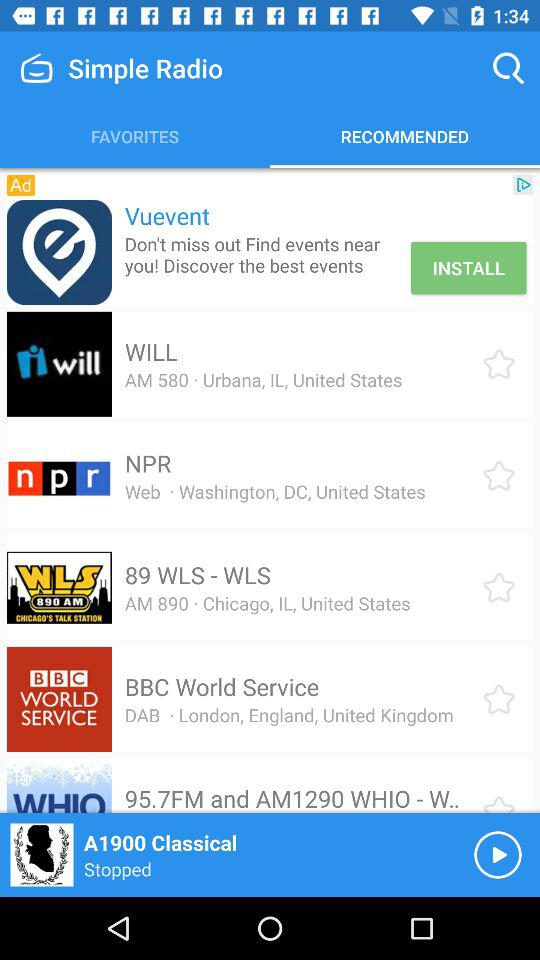What is the address of NPR radio? The address is Washington, DC, United States. 